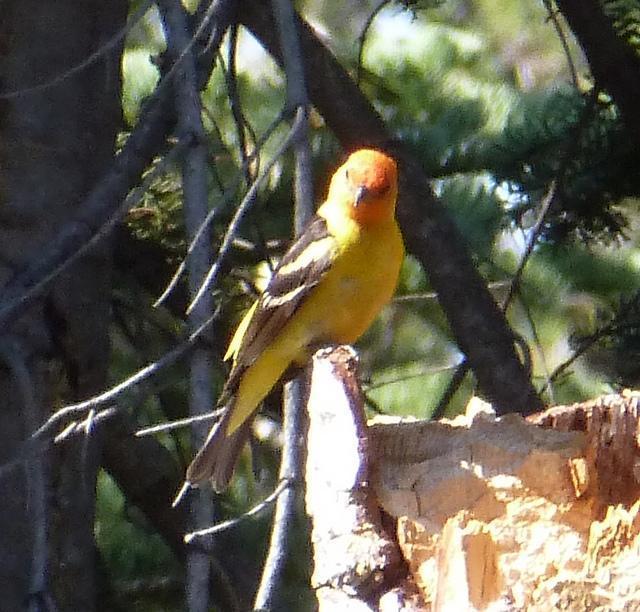How many signs have bus icon on a pole?
Give a very brief answer. 0. 